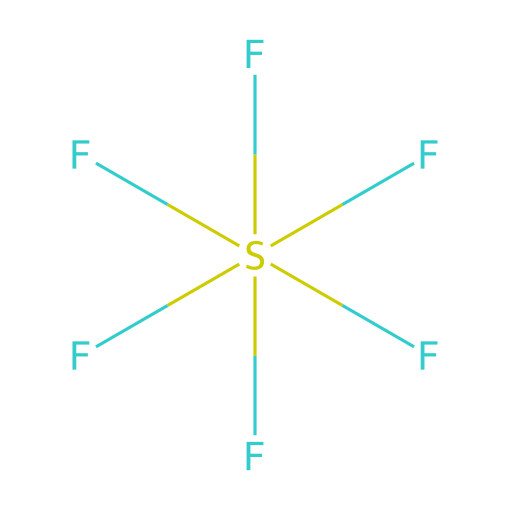What is the molecular formula for sulfur hexafluoride? The SMILES representation indicates one sulfur (S) atom and six fluorine (F) atoms, leading to the molecular formula SF6.
Answer: SF6 How many fluorine atoms are present in this compound? The visual representation shows six fluorine (F) atoms connected to one sulfur (S) atom.
Answer: six What type of bonding is present in sulfur hexafluoride? The SMILES structure reveals that sulfur is surrounded by six fluorine atoms, indicating that these bonds are covalent due to the shared electron pairs between sulfur and fluorine.
Answer: covalent Is sulfur hexafluoride a polar or nonpolar molecule? Given the symmetrical arrangement of fluorine atoms around the sulfur atom in the structure, the molecule is nonpolar as the dipoles cancel each other out.
Answer: nonpolar What is the primary use of sulfur hexafluoride? Sulfur hexafluoride is primarily used in electrical insulation, especially in high-voltage applications, due to its excellent dielectric properties.
Answer: electrical insulation How does the presence of sulfur contribute to the properties of the compound? Sulfur provides a central atom that allows the bonding with multiple fluorine atoms, influencing the overall molecular symmetry and electronegativity, which are critical for its insulating properties.
Answer: central atom What environmental concern is associated with sulfur hexafluoride? Sulfur hexafluoride is a potent greenhouse gas with a very high global warming potential, contributing to climate change when released into the atmosphere.
Answer: greenhouse gas 